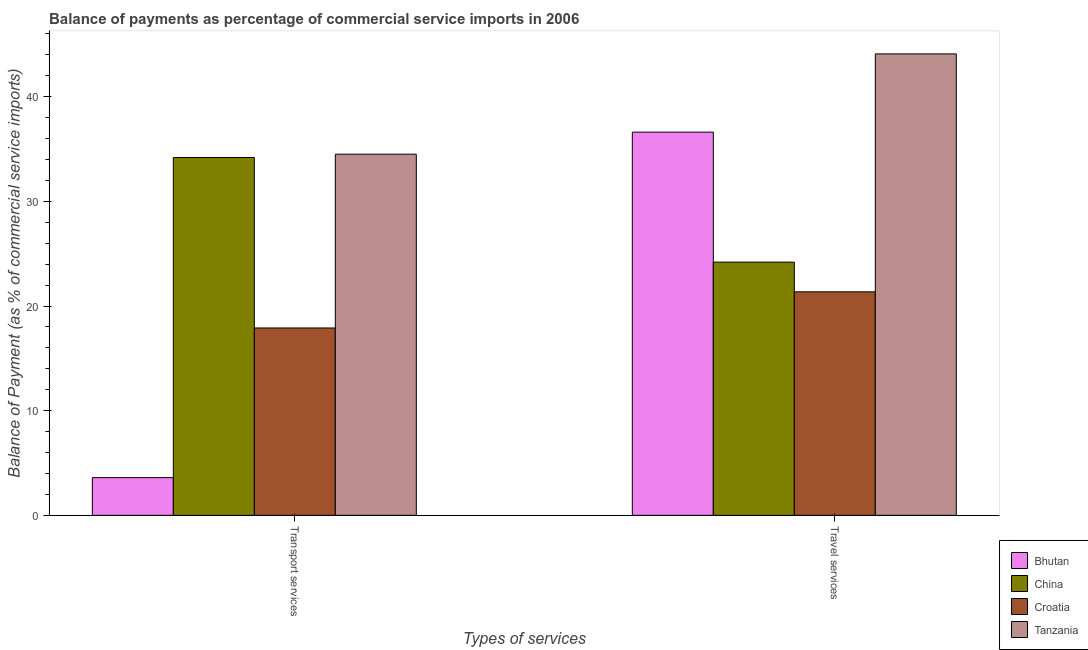How many groups of bars are there?
Make the answer very short. 2. Are the number of bars per tick equal to the number of legend labels?
Offer a very short reply. Yes. How many bars are there on the 1st tick from the left?
Offer a very short reply. 4. How many bars are there on the 1st tick from the right?
Make the answer very short. 4. What is the label of the 2nd group of bars from the left?
Make the answer very short. Travel services. What is the balance of payments of travel services in Bhutan?
Ensure brevity in your answer.  36.61. Across all countries, what is the maximum balance of payments of transport services?
Your response must be concise. 34.51. Across all countries, what is the minimum balance of payments of travel services?
Make the answer very short. 21.35. In which country was the balance of payments of transport services maximum?
Make the answer very short. Tanzania. In which country was the balance of payments of transport services minimum?
Ensure brevity in your answer.  Bhutan. What is the total balance of payments of travel services in the graph?
Offer a very short reply. 126.25. What is the difference between the balance of payments of travel services in Tanzania and that in Bhutan?
Offer a terse response. 7.48. What is the difference between the balance of payments of transport services in China and the balance of payments of travel services in Croatia?
Offer a terse response. 12.83. What is the average balance of payments of travel services per country?
Give a very brief answer. 31.56. What is the difference between the balance of payments of transport services and balance of payments of travel services in Croatia?
Give a very brief answer. -3.45. In how many countries, is the balance of payments of transport services greater than 22 %?
Your answer should be compact. 2. What is the ratio of the balance of payments of travel services in Croatia to that in Tanzania?
Ensure brevity in your answer.  0.48. In how many countries, is the balance of payments of travel services greater than the average balance of payments of travel services taken over all countries?
Your answer should be compact. 2. What does the 1st bar from the left in Travel services represents?
Ensure brevity in your answer.  Bhutan. What does the 2nd bar from the right in Travel services represents?
Your answer should be very brief. Croatia. How many bars are there?
Give a very brief answer. 8. How many countries are there in the graph?
Your answer should be very brief. 4. Are the values on the major ticks of Y-axis written in scientific E-notation?
Your response must be concise. No. Does the graph contain grids?
Your answer should be compact. No. How many legend labels are there?
Give a very brief answer. 4. How are the legend labels stacked?
Provide a succinct answer. Vertical. What is the title of the graph?
Your answer should be compact. Balance of payments as percentage of commercial service imports in 2006. Does "Czech Republic" appear as one of the legend labels in the graph?
Provide a succinct answer. No. What is the label or title of the X-axis?
Your answer should be very brief. Types of services. What is the label or title of the Y-axis?
Offer a very short reply. Balance of Payment (as % of commercial service imports). What is the Balance of Payment (as % of commercial service imports) of Bhutan in Transport services?
Make the answer very short. 3.6. What is the Balance of Payment (as % of commercial service imports) in China in Transport services?
Keep it short and to the point. 34.19. What is the Balance of Payment (as % of commercial service imports) in Croatia in Transport services?
Ensure brevity in your answer.  17.9. What is the Balance of Payment (as % of commercial service imports) of Tanzania in Transport services?
Your answer should be very brief. 34.51. What is the Balance of Payment (as % of commercial service imports) in Bhutan in Travel services?
Your answer should be compact. 36.61. What is the Balance of Payment (as % of commercial service imports) of China in Travel services?
Ensure brevity in your answer.  24.19. What is the Balance of Payment (as % of commercial service imports) in Croatia in Travel services?
Provide a short and direct response. 21.35. What is the Balance of Payment (as % of commercial service imports) in Tanzania in Travel services?
Your answer should be compact. 44.09. Across all Types of services, what is the maximum Balance of Payment (as % of commercial service imports) of Bhutan?
Ensure brevity in your answer.  36.61. Across all Types of services, what is the maximum Balance of Payment (as % of commercial service imports) in China?
Offer a very short reply. 34.19. Across all Types of services, what is the maximum Balance of Payment (as % of commercial service imports) of Croatia?
Ensure brevity in your answer.  21.35. Across all Types of services, what is the maximum Balance of Payment (as % of commercial service imports) in Tanzania?
Your answer should be compact. 44.09. Across all Types of services, what is the minimum Balance of Payment (as % of commercial service imports) of Bhutan?
Give a very brief answer. 3.6. Across all Types of services, what is the minimum Balance of Payment (as % of commercial service imports) in China?
Offer a very short reply. 24.19. Across all Types of services, what is the minimum Balance of Payment (as % of commercial service imports) in Croatia?
Your answer should be very brief. 17.9. Across all Types of services, what is the minimum Balance of Payment (as % of commercial service imports) in Tanzania?
Give a very brief answer. 34.51. What is the total Balance of Payment (as % of commercial service imports) of Bhutan in the graph?
Provide a short and direct response. 40.22. What is the total Balance of Payment (as % of commercial service imports) in China in the graph?
Provide a succinct answer. 58.38. What is the total Balance of Payment (as % of commercial service imports) of Croatia in the graph?
Your response must be concise. 39.26. What is the total Balance of Payment (as % of commercial service imports) of Tanzania in the graph?
Give a very brief answer. 78.59. What is the difference between the Balance of Payment (as % of commercial service imports) of Bhutan in Transport services and that in Travel services?
Make the answer very short. -33.01. What is the difference between the Balance of Payment (as % of commercial service imports) of China in Transport services and that in Travel services?
Keep it short and to the point. 9.99. What is the difference between the Balance of Payment (as % of commercial service imports) in Croatia in Transport services and that in Travel services?
Your response must be concise. -3.45. What is the difference between the Balance of Payment (as % of commercial service imports) in Tanzania in Transport services and that in Travel services?
Offer a terse response. -9.58. What is the difference between the Balance of Payment (as % of commercial service imports) of Bhutan in Transport services and the Balance of Payment (as % of commercial service imports) of China in Travel services?
Provide a succinct answer. -20.59. What is the difference between the Balance of Payment (as % of commercial service imports) in Bhutan in Transport services and the Balance of Payment (as % of commercial service imports) in Croatia in Travel services?
Provide a short and direct response. -17.75. What is the difference between the Balance of Payment (as % of commercial service imports) in Bhutan in Transport services and the Balance of Payment (as % of commercial service imports) in Tanzania in Travel services?
Ensure brevity in your answer.  -40.48. What is the difference between the Balance of Payment (as % of commercial service imports) of China in Transport services and the Balance of Payment (as % of commercial service imports) of Croatia in Travel services?
Your answer should be compact. 12.83. What is the difference between the Balance of Payment (as % of commercial service imports) of China in Transport services and the Balance of Payment (as % of commercial service imports) of Tanzania in Travel services?
Provide a succinct answer. -9.9. What is the difference between the Balance of Payment (as % of commercial service imports) of Croatia in Transport services and the Balance of Payment (as % of commercial service imports) of Tanzania in Travel services?
Offer a terse response. -26.19. What is the average Balance of Payment (as % of commercial service imports) in Bhutan per Types of services?
Provide a succinct answer. 20.11. What is the average Balance of Payment (as % of commercial service imports) of China per Types of services?
Ensure brevity in your answer.  29.19. What is the average Balance of Payment (as % of commercial service imports) in Croatia per Types of services?
Ensure brevity in your answer.  19.63. What is the average Balance of Payment (as % of commercial service imports) of Tanzania per Types of services?
Provide a short and direct response. 39.3. What is the difference between the Balance of Payment (as % of commercial service imports) of Bhutan and Balance of Payment (as % of commercial service imports) of China in Transport services?
Offer a terse response. -30.58. What is the difference between the Balance of Payment (as % of commercial service imports) in Bhutan and Balance of Payment (as % of commercial service imports) in Croatia in Transport services?
Offer a very short reply. -14.3. What is the difference between the Balance of Payment (as % of commercial service imports) of Bhutan and Balance of Payment (as % of commercial service imports) of Tanzania in Transport services?
Your response must be concise. -30.9. What is the difference between the Balance of Payment (as % of commercial service imports) in China and Balance of Payment (as % of commercial service imports) in Croatia in Transport services?
Provide a short and direct response. 16.29. What is the difference between the Balance of Payment (as % of commercial service imports) in China and Balance of Payment (as % of commercial service imports) in Tanzania in Transport services?
Offer a very short reply. -0.32. What is the difference between the Balance of Payment (as % of commercial service imports) in Croatia and Balance of Payment (as % of commercial service imports) in Tanzania in Transport services?
Ensure brevity in your answer.  -16.6. What is the difference between the Balance of Payment (as % of commercial service imports) in Bhutan and Balance of Payment (as % of commercial service imports) in China in Travel services?
Your answer should be compact. 12.42. What is the difference between the Balance of Payment (as % of commercial service imports) of Bhutan and Balance of Payment (as % of commercial service imports) of Croatia in Travel services?
Give a very brief answer. 15.26. What is the difference between the Balance of Payment (as % of commercial service imports) in Bhutan and Balance of Payment (as % of commercial service imports) in Tanzania in Travel services?
Provide a succinct answer. -7.48. What is the difference between the Balance of Payment (as % of commercial service imports) of China and Balance of Payment (as % of commercial service imports) of Croatia in Travel services?
Offer a terse response. 2.84. What is the difference between the Balance of Payment (as % of commercial service imports) of China and Balance of Payment (as % of commercial service imports) of Tanzania in Travel services?
Provide a short and direct response. -19.89. What is the difference between the Balance of Payment (as % of commercial service imports) in Croatia and Balance of Payment (as % of commercial service imports) in Tanzania in Travel services?
Give a very brief answer. -22.73. What is the ratio of the Balance of Payment (as % of commercial service imports) of Bhutan in Transport services to that in Travel services?
Provide a short and direct response. 0.1. What is the ratio of the Balance of Payment (as % of commercial service imports) in China in Transport services to that in Travel services?
Keep it short and to the point. 1.41. What is the ratio of the Balance of Payment (as % of commercial service imports) in Croatia in Transport services to that in Travel services?
Give a very brief answer. 0.84. What is the ratio of the Balance of Payment (as % of commercial service imports) in Tanzania in Transport services to that in Travel services?
Keep it short and to the point. 0.78. What is the difference between the highest and the second highest Balance of Payment (as % of commercial service imports) of Bhutan?
Make the answer very short. 33.01. What is the difference between the highest and the second highest Balance of Payment (as % of commercial service imports) of China?
Keep it short and to the point. 9.99. What is the difference between the highest and the second highest Balance of Payment (as % of commercial service imports) of Croatia?
Keep it short and to the point. 3.45. What is the difference between the highest and the second highest Balance of Payment (as % of commercial service imports) of Tanzania?
Provide a short and direct response. 9.58. What is the difference between the highest and the lowest Balance of Payment (as % of commercial service imports) of Bhutan?
Ensure brevity in your answer.  33.01. What is the difference between the highest and the lowest Balance of Payment (as % of commercial service imports) in China?
Your answer should be compact. 9.99. What is the difference between the highest and the lowest Balance of Payment (as % of commercial service imports) in Croatia?
Offer a terse response. 3.45. What is the difference between the highest and the lowest Balance of Payment (as % of commercial service imports) of Tanzania?
Keep it short and to the point. 9.58. 